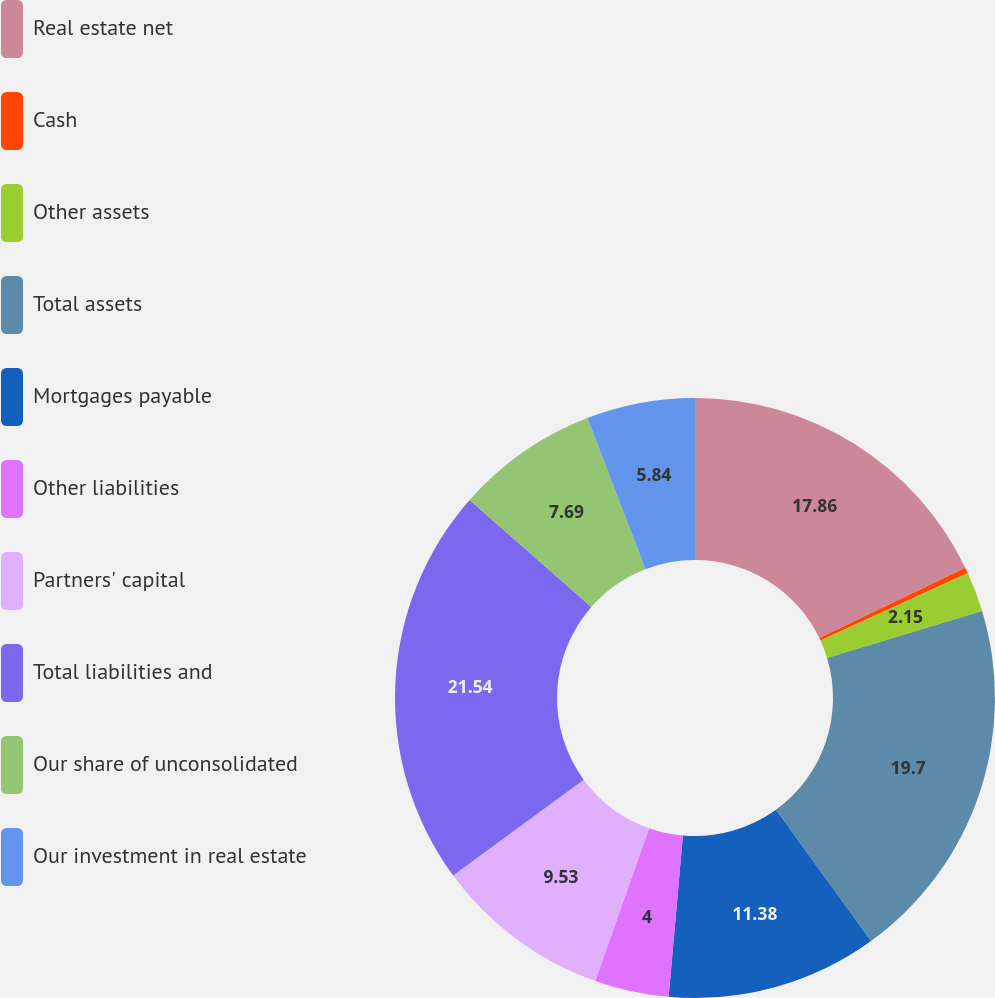<chart> <loc_0><loc_0><loc_500><loc_500><pie_chart><fcel>Real estate net<fcel>Cash<fcel>Other assets<fcel>Total assets<fcel>Mortgages payable<fcel>Other liabilities<fcel>Partners' capital<fcel>Total liabilities and<fcel>Our share of unconsolidated<fcel>Our investment in real estate<nl><fcel>17.86%<fcel>0.31%<fcel>2.15%<fcel>19.71%<fcel>11.38%<fcel>4.0%<fcel>9.53%<fcel>21.55%<fcel>7.69%<fcel>5.84%<nl></chart> 